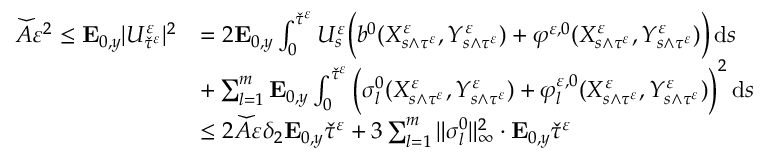Convert formula to latex. <formula><loc_0><loc_0><loc_500><loc_500>\begin{array} { r l } { \ w i d e c h e c k A \varepsilon ^ { 2 } \leq E _ { 0 , y } | U _ { \ w i d e c h e c k \tau ^ { \varepsilon } } ^ { \varepsilon } | ^ { 2 } } & { = 2 E _ { 0 , y } \int _ { 0 } ^ { \ w i d e c h e c k \tau ^ { \varepsilon } } U _ { s } ^ { \varepsilon } \left ( b ^ { 0 } ( X _ { s \wedge \tau ^ { \varepsilon } } ^ { \varepsilon } , Y _ { s \wedge \tau ^ { \varepsilon } } ^ { \varepsilon } ) + \varphi ^ { \varepsilon , 0 } ( X _ { s \wedge \tau ^ { \varepsilon } } ^ { \varepsilon } , Y _ { s \wedge \tau ^ { \varepsilon } } ^ { \varepsilon } ) \right ) \, d s } \\ & { + \sum _ { l = 1 } ^ { m } E _ { 0 , y } \int _ { 0 } ^ { \ w i d e c h e c k \tau ^ { \varepsilon } } \left ( \sigma _ { l } ^ { 0 } ( X _ { s \wedge \tau ^ { \varepsilon } } ^ { \varepsilon } , Y _ { s \wedge \tau ^ { \varepsilon } } ^ { \varepsilon } ) + \varphi _ { l } ^ { \varepsilon , 0 } ( X _ { s \wedge \tau ^ { \varepsilon } } ^ { \varepsilon } , Y _ { s \wedge \tau ^ { \varepsilon } } ^ { \varepsilon } ) \right ) ^ { 2 } \, d s } \\ & { \leq 2 \ w i d e c h e c k A \varepsilon \delta _ { 2 } E _ { 0 , y } \ w i d e c h e c k \tau ^ { \varepsilon } + 3 \sum _ { l = 1 } ^ { m } \| \sigma _ { l } ^ { 0 } \| _ { \infty } ^ { 2 } \cdot E _ { 0 , y } \ w i d e c h e c k \tau ^ { \varepsilon } } \end{array}</formula> 